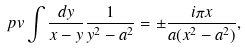<formula> <loc_0><loc_0><loc_500><loc_500>\ p v \int \frac { d y } { x - y } \frac { 1 } { y ^ { 2 } - a ^ { 2 } } = \pm \frac { i \pi x } { a ( x ^ { 2 } - a ^ { 2 } ) } ,</formula> 